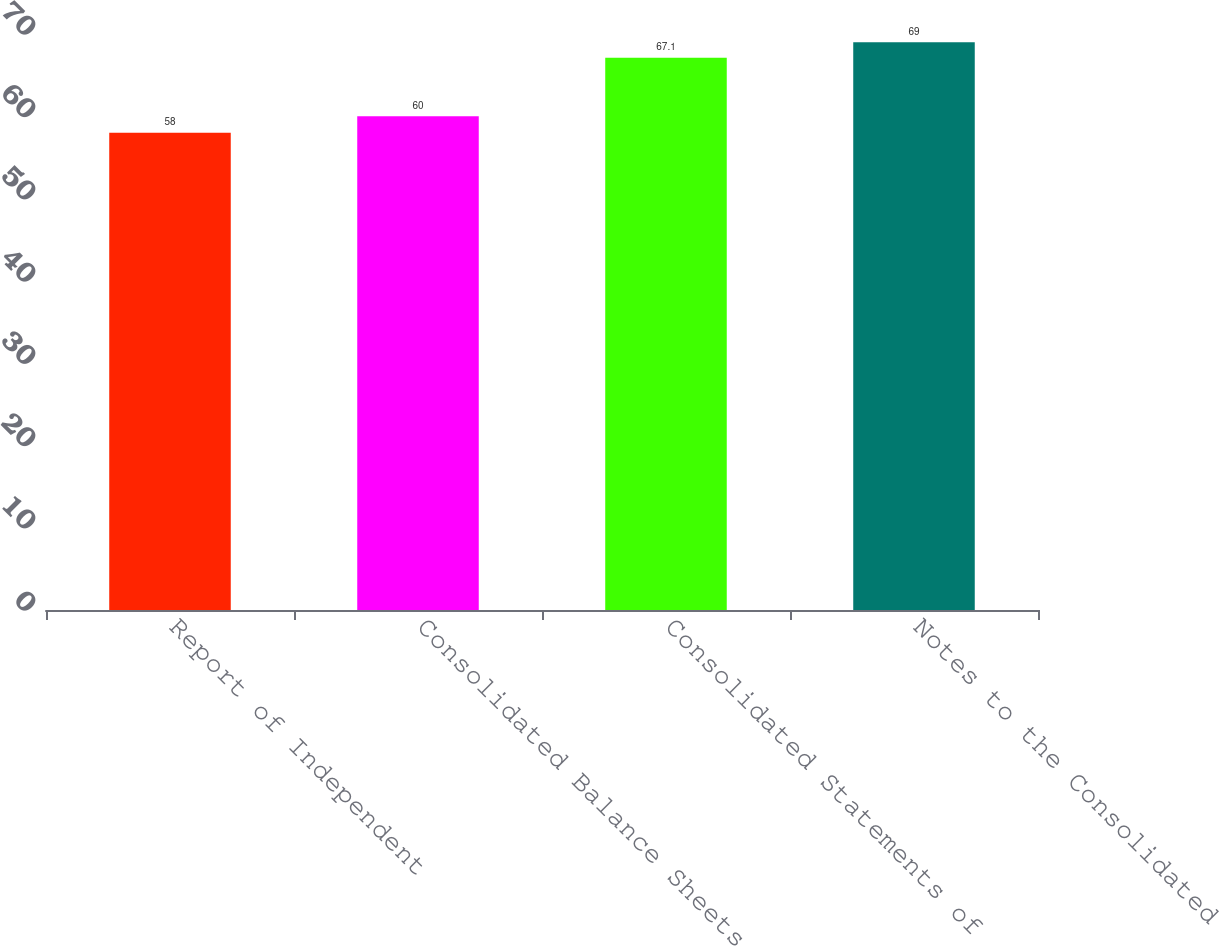Convert chart. <chart><loc_0><loc_0><loc_500><loc_500><bar_chart><fcel>Report of Independent<fcel>Consolidated Balance Sheets<fcel>Consolidated Statements of<fcel>Notes to the Consolidated<nl><fcel>58<fcel>60<fcel>67.1<fcel>69<nl></chart> 